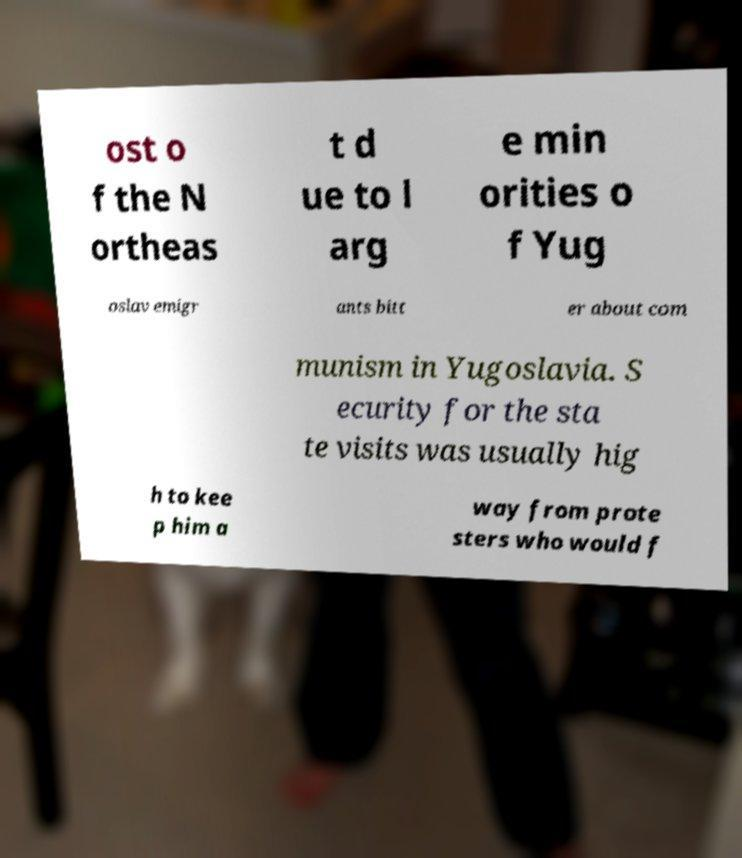For documentation purposes, I need the text within this image transcribed. Could you provide that? ost o f the N ortheas t d ue to l arg e min orities o f Yug oslav emigr ants bitt er about com munism in Yugoslavia. S ecurity for the sta te visits was usually hig h to kee p him a way from prote sters who would f 